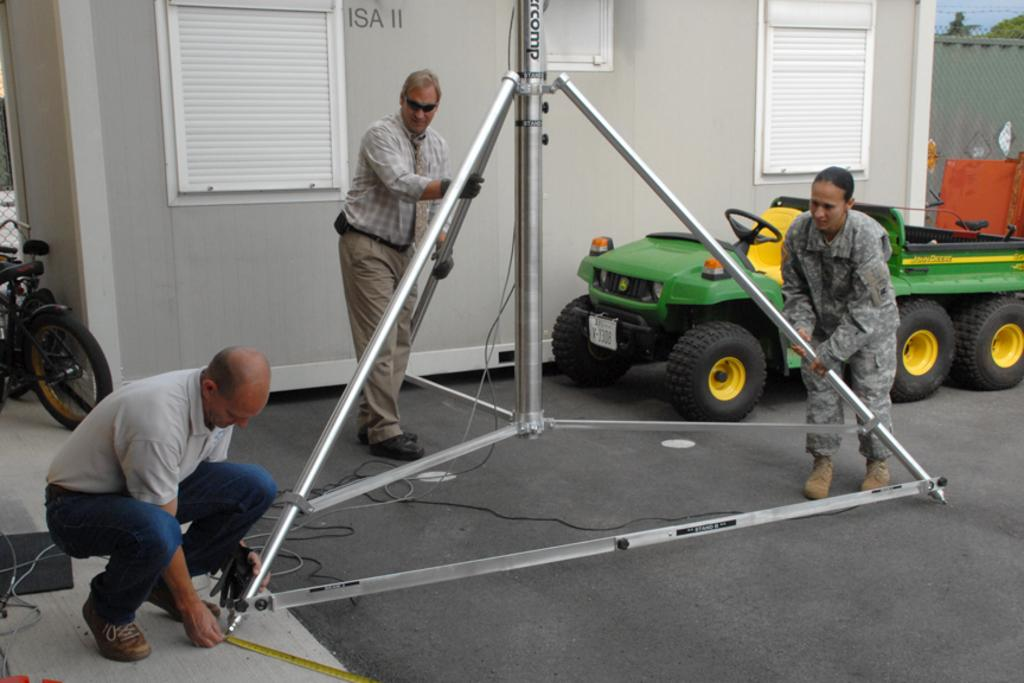How many people are in the image? There are two men and a woman in the image. What are the individuals doing in the image? The individuals are working with iron rods. What can be seen in the background of the image? There is a vehicle, a bicycle, and a shed in the background of the image. What type of pancake is the woman flipping in the image? There is no pancake present in the image; the individuals are working with iron rods. What subject is the woman learning about in the image? There is no indication in the image that the woman is learning about any specific subject. 